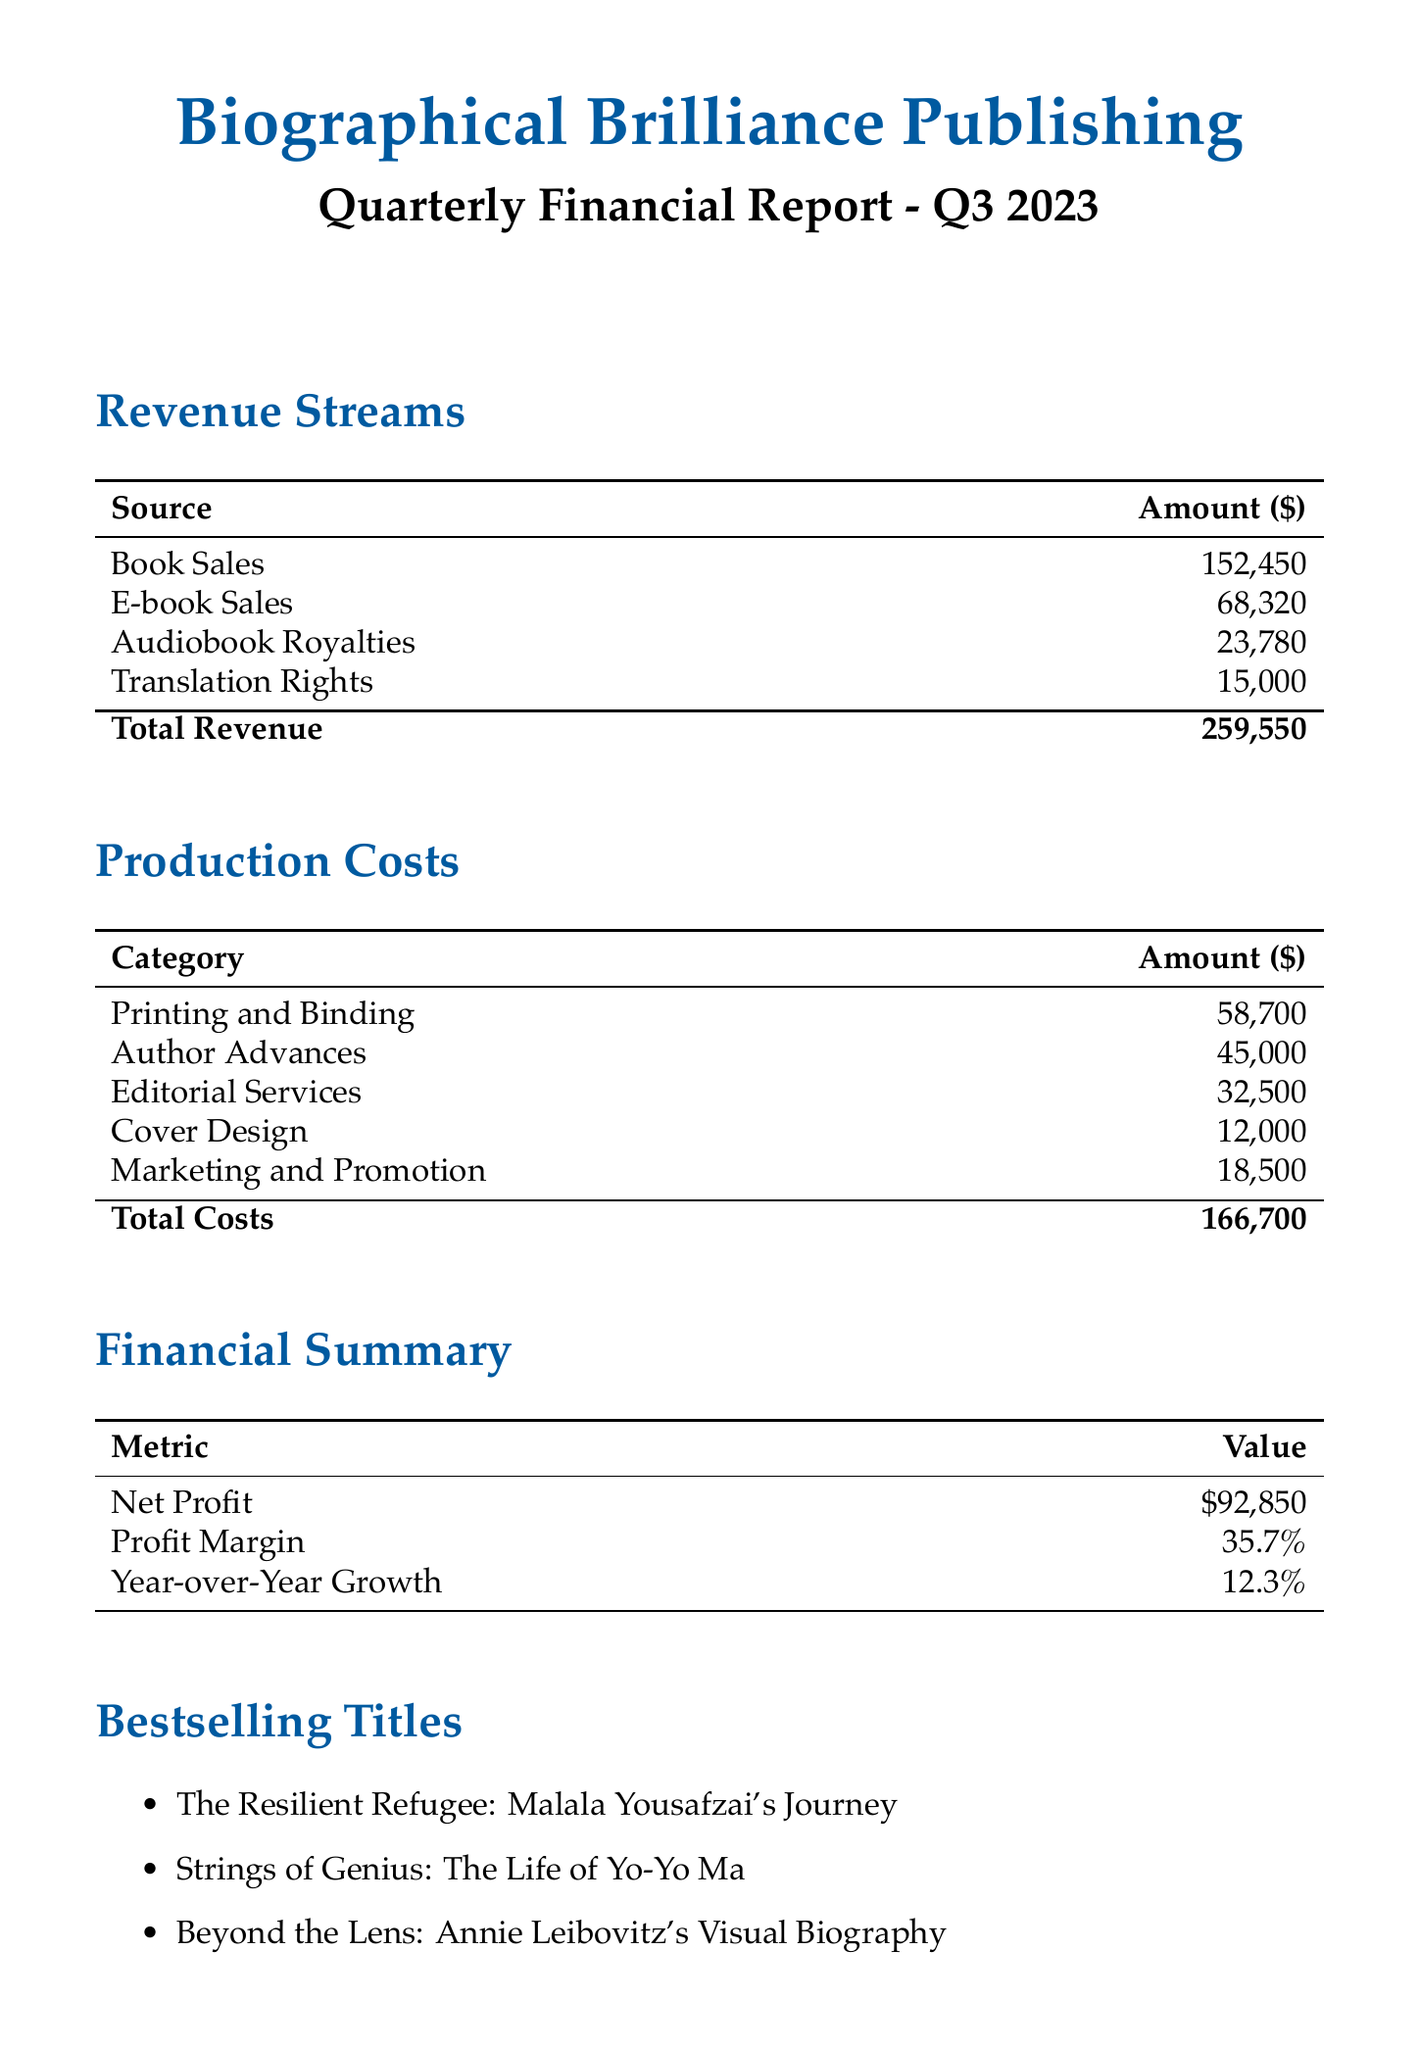What is the total revenue? The total revenue is the sum of all revenue sources in the document: $152,450 + $68,320 + $23,780 + $15,000 = $259,550.
Answer: $259,550 What is the amount for Author Advances? The Author Advances in the production costs section is listed as $45,000.
Answer: $45,000 What is the profit margin percentage? The profit margin percentage is presented in the financial summary section as 35.7%.
Answer: 35.7% Which title is the bestselling for Q3 2023? The bestselling titles are listed, and one of them is "The Resilient Refugee: Malala Yousafzai's Journey."
Answer: The Resilient Refugee: Malala Yousafzai's Journey What is the year-over-year growth percentage? The year-over-year growth percentage is stated in the financial summary as 12.3%.
Answer: 12.3% What is the total cost of production? The total costs are calculated and shown in the document as $166,700.
Answer: $166,700 Which upcoming release focuses on Frida Kahlo? The upcoming release mentioning Frida Kahlo is "Brushstrokes of Change: Frida Kahlo's Artistic Revolution."
Answer: Brushstrokes of Change: Frida Kahlo's Artistic Revolution How much is earned from Audiobook Royalties? The Audiobook Royalties in the revenue streams section is given as $23,780.
Answer: $23,780 